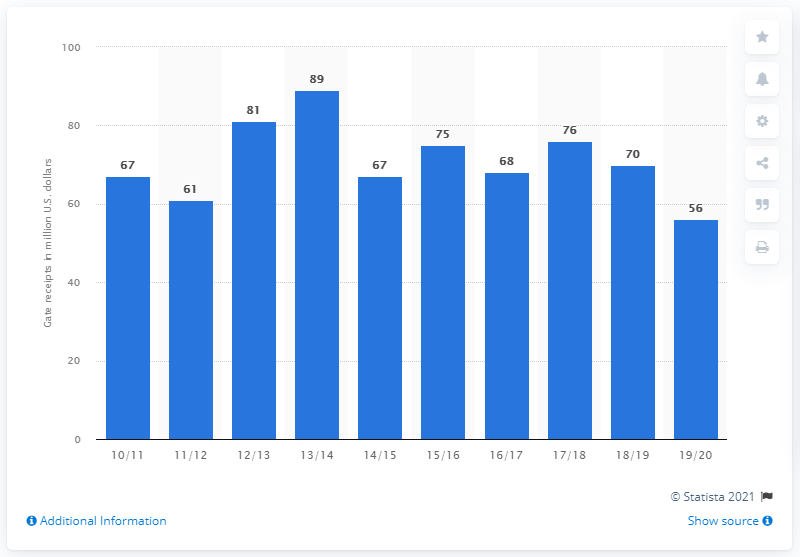Highlight a few significant elements in this photo. The gate receipts of the Miami Heat in the 2019/20 season were $56. 